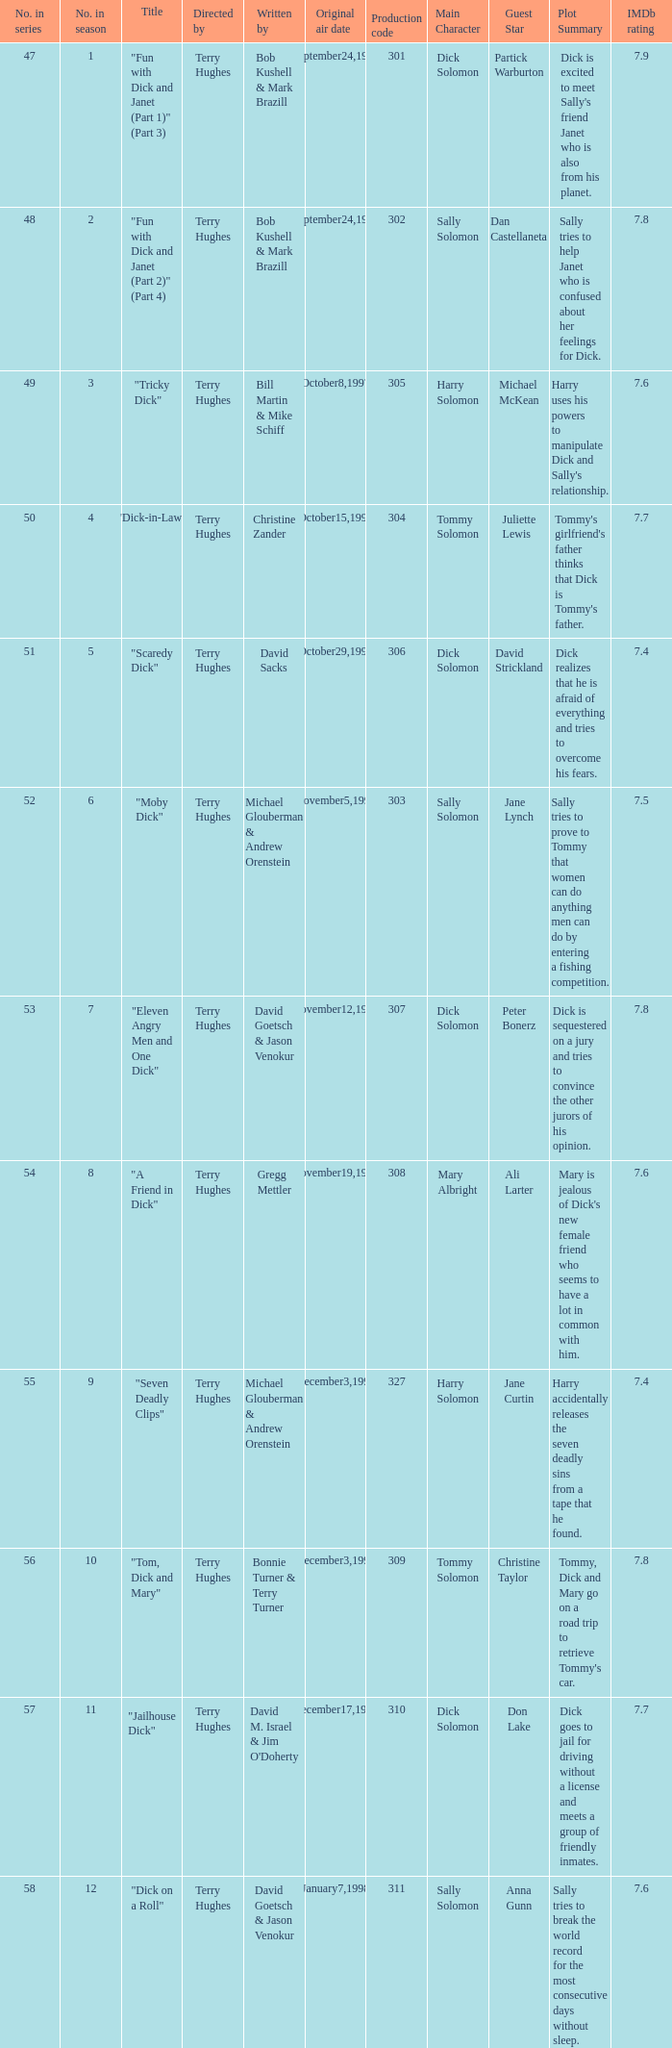What is the title of episode 10? "Tom, Dick and Mary". 